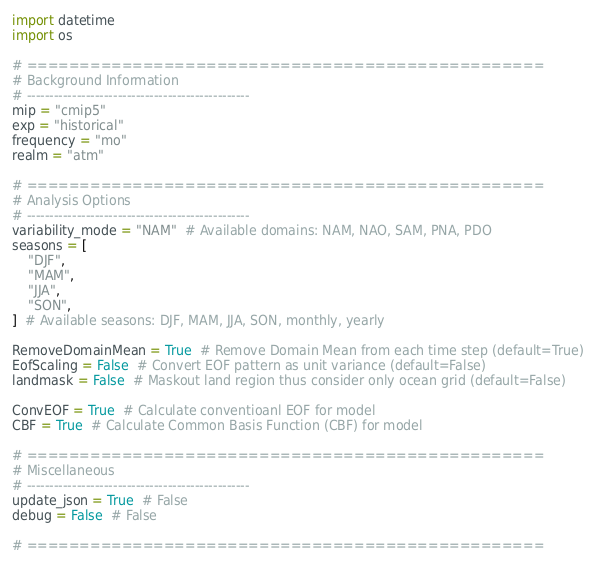<code> <loc_0><loc_0><loc_500><loc_500><_Python_>import datetime
import os

# =================================================
# Background Information
# -------------------------------------------------
mip = "cmip5"
exp = "historical"
frequency = "mo"
realm = "atm"

# =================================================
# Analysis Options
# -------------------------------------------------
variability_mode = "NAM"  # Available domains: NAM, NAO, SAM, PNA, PDO
seasons = [
    "DJF",
    "MAM",
    "JJA",
    "SON",
]  # Available seasons: DJF, MAM, JJA, SON, monthly, yearly

RemoveDomainMean = True  # Remove Domain Mean from each time step (default=True)
EofScaling = False  # Convert EOF pattern as unit variance (default=False)
landmask = False  # Maskout land region thus consider only ocean grid (default=False)

ConvEOF = True  # Calculate conventioanl EOF for model
CBF = True  # Calculate Common Basis Function (CBF) for model

# =================================================
# Miscellaneous
# -------------------------------------------------
update_json = True  # False
debug = False  # False

# =================================================</code> 